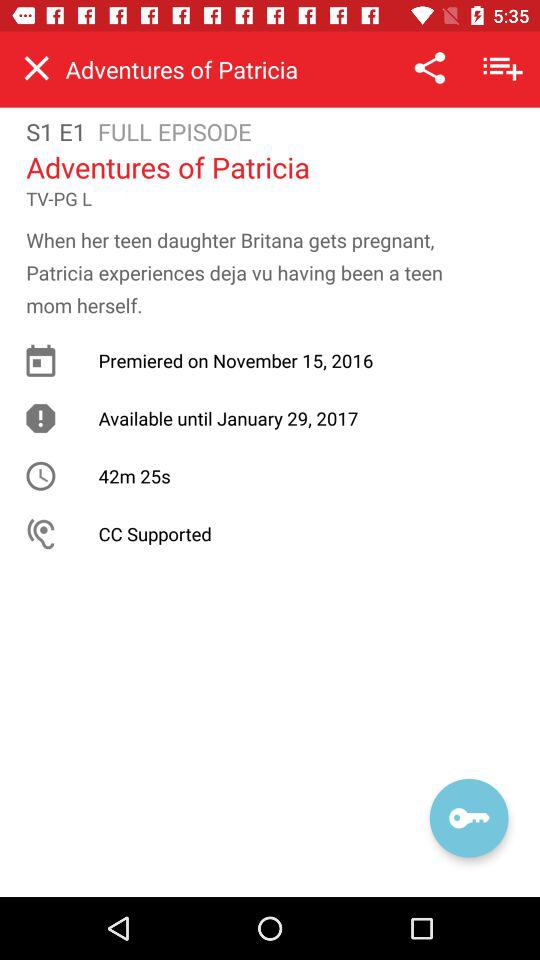What is the name of the series? The name of the series is "Adventures of Patricia". 